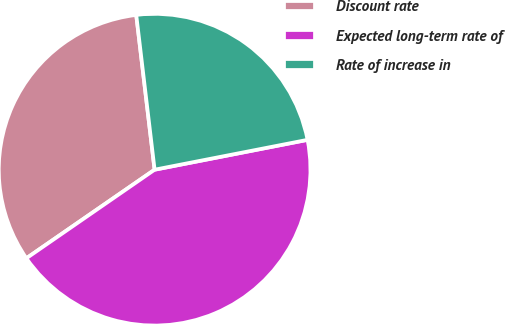Convert chart. <chart><loc_0><loc_0><loc_500><loc_500><pie_chart><fcel>Discount rate<fcel>Expected long-term rate of<fcel>Rate of increase in<nl><fcel>32.74%<fcel>43.45%<fcel>23.81%<nl></chart> 